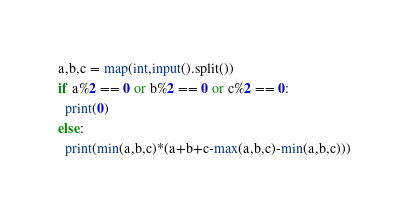Convert code to text. <code><loc_0><loc_0><loc_500><loc_500><_Python_>a,b,c = map(int,input().split())
if a%2 == 0 or b%2 == 0 or c%2 == 0:
  print(0)
else:
  print(min(a,b,c)*(a+b+c-max(a,b,c)-min(a,b,c)))</code> 